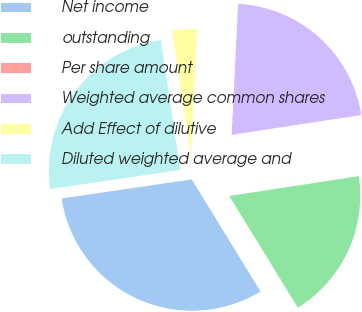Convert chart to OTSL. <chart><loc_0><loc_0><loc_500><loc_500><pie_chart><fcel>Net income<fcel>outstanding<fcel>Per share amount<fcel>Weighted average common shares<fcel>Add Effect of dilutive<fcel>Diluted weighted average and<nl><fcel>31.45%<fcel>18.66%<fcel>0.0%<fcel>21.8%<fcel>3.15%<fcel>24.95%<nl></chart> 